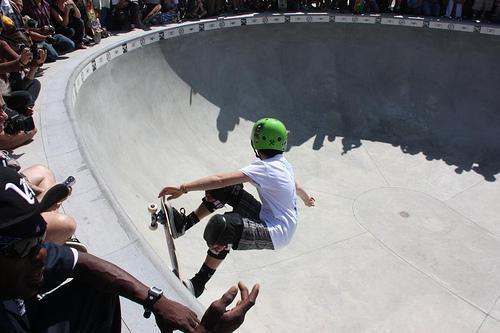How many helmets are there?
Give a very brief answer. 1. How many people are visible?
Give a very brief answer. 3. 